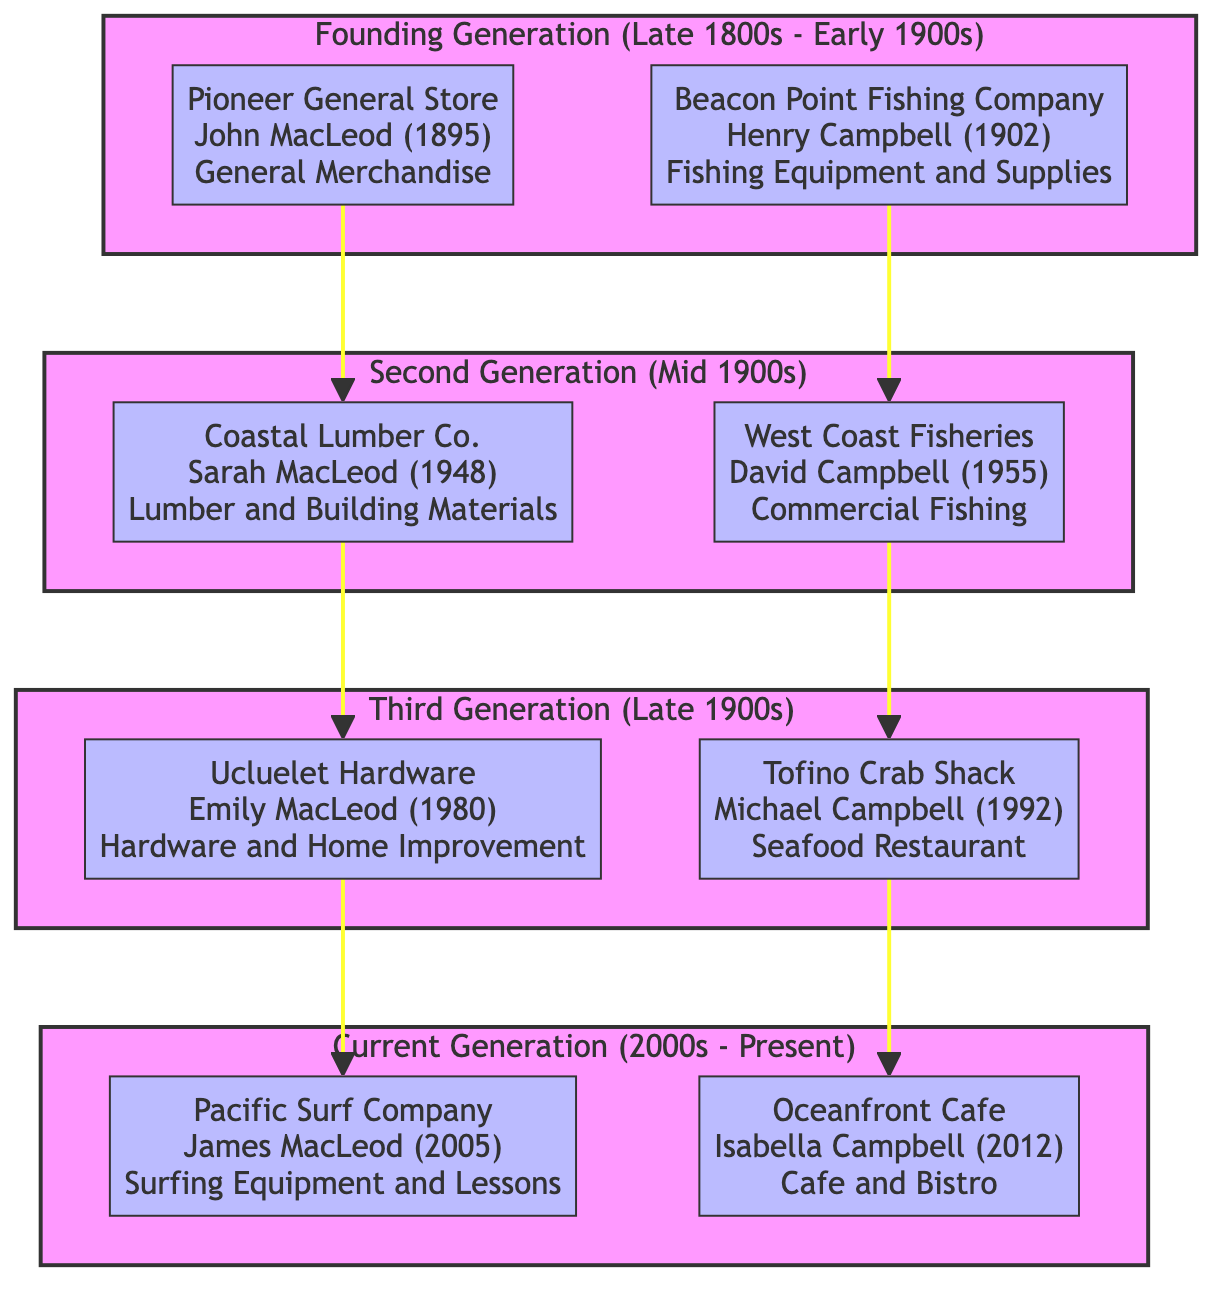What is the name of the business founded by John MacLeod? The diagram shows that the business founded by John MacLeod in the Founding Generation is "Pioneer General Store."
Answer: Pioneer General Store Which year was Coastal Lumber Co. established? According to the diagram, Coastal Lumber Co. was established in 1948, as indicated in the Second Generation section.
Answer: 1948 Who is the daughter of Sarah MacLeod? Looking at the flow, Emily MacLeod is shown as the daughter of Sarah MacLeod and she founded Ucluelet Hardware.
Answer: Emily MacLeod What type of business is the Oceanfront Cafe? In the Current Generation section, Oceanfront Cafe is described as a "Cafe and Bistro."
Answer: Cafe and Bistro How many businesses are there in the Founding Generation? By examining the diagram, there are 2 businesses listed in the Founding Generation, namely Pioneer General Store and Beacon Point Fishing Company.
Answer: 2 Which business is the parent of Pacific Surf Company? The diagram indicates that Ucluelet Hardware is the parent of Pacific Surf Company, as described in the relationship connected by an arrow from UH to PSC.
Answer: Ucluelet Hardware What year was Tofino Crab Shack established? In the Third Generation section of the diagram, Tofino Crab Shack is established in 1992.
Answer: 1992 Who is the founder of West Coast Fisheries? The diagram specifies that West Coast Fisheries was founded by David Campbell, as seen in the Second Generation section.
Answer: David Campbell Which business follows Coastal Lumber Co. in the family tree? According to the flow, Ucluelet Hardware follows Coastal Lumber Co. as indicated by the directional arrow between the two businesses.
Answer: Ucluelet Hardware 